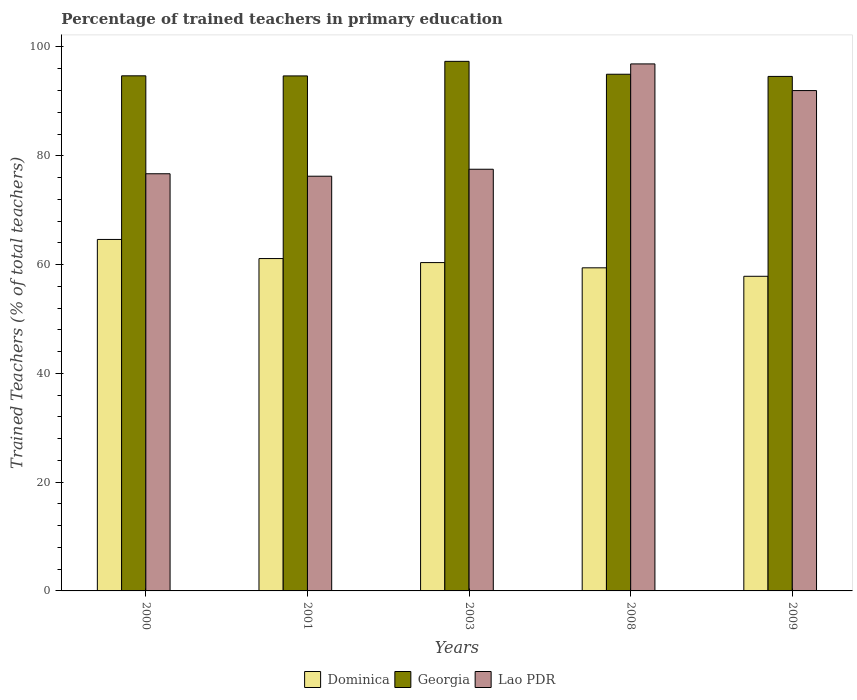How many groups of bars are there?
Ensure brevity in your answer.  5. Are the number of bars on each tick of the X-axis equal?
Your answer should be compact. Yes. How many bars are there on the 2nd tick from the left?
Offer a very short reply. 3. How many bars are there on the 2nd tick from the right?
Offer a very short reply. 3. What is the label of the 4th group of bars from the left?
Give a very brief answer. 2008. In how many cases, is the number of bars for a given year not equal to the number of legend labels?
Offer a very short reply. 0. What is the percentage of trained teachers in Dominica in 2000?
Offer a very short reply. 64.62. Across all years, what is the maximum percentage of trained teachers in Lao PDR?
Your response must be concise. 96.89. Across all years, what is the minimum percentage of trained teachers in Georgia?
Make the answer very short. 94.59. In which year was the percentage of trained teachers in Dominica minimum?
Provide a succinct answer. 2009. What is the total percentage of trained teachers in Dominica in the graph?
Offer a very short reply. 303.33. What is the difference between the percentage of trained teachers in Georgia in 2000 and that in 2009?
Your answer should be very brief. 0.11. What is the difference between the percentage of trained teachers in Georgia in 2008 and the percentage of trained teachers in Lao PDR in 2003?
Your answer should be very brief. 17.47. What is the average percentage of trained teachers in Georgia per year?
Your response must be concise. 95.26. In the year 2008, what is the difference between the percentage of trained teachers in Dominica and percentage of trained teachers in Lao PDR?
Provide a succinct answer. -37.49. In how many years, is the percentage of trained teachers in Dominica greater than 88 %?
Give a very brief answer. 0. What is the ratio of the percentage of trained teachers in Georgia in 2003 to that in 2008?
Offer a very short reply. 1.02. Is the percentage of trained teachers in Dominica in 2008 less than that in 2009?
Give a very brief answer. No. Is the difference between the percentage of trained teachers in Dominica in 2003 and 2009 greater than the difference between the percentage of trained teachers in Lao PDR in 2003 and 2009?
Keep it short and to the point. Yes. What is the difference between the highest and the second highest percentage of trained teachers in Dominica?
Provide a short and direct response. 3.52. What is the difference between the highest and the lowest percentage of trained teachers in Lao PDR?
Offer a very short reply. 20.64. In how many years, is the percentage of trained teachers in Lao PDR greater than the average percentage of trained teachers in Lao PDR taken over all years?
Keep it short and to the point. 2. Is the sum of the percentage of trained teachers in Dominica in 2003 and 2008 greater than the maximum percentage of trained teachers in Lao PDR across all years?
Offer a terse response. Yes. What does the 1st bar from the left in 2009 represents?
Provide a short and direct response. Dominica. What does the 1st bar from the right in 2003 represents?
Your answer should be compact. Lao PDR. How many bars are there?
Your answer should be very brief. 15. Are all the bars in the graph horizontal?
Give a very brief answer. No. How many years are there in the graph?
Ensure brevity in your answer.  5. What is the difference between two consecutive major ticks on the Y-axis?
Offer a terse response. 20. Where does the legend appear in the graph?
Offer a very short reply. Bottom center. How many legend labels are there?
Keep it short and to the point. 3. How are the legend labels stacked?
Make the answer very short. Horizontal. What is the title of the graph?
Provide a succinct answer. Percentage of trained teachers in primary education. Does "Euro area" appear as one of the legend labels in the graph?
Provide a short and direct response. No. What is the label or title of the Y-axis?
Your response must be concise. Trained Teachers (% of total teachers). What is the Trained Teachers (% of total teachers) in Dominica in 2000?
Your answer should be compact. 64.62. What is the Trained Teachers (% of total teachers) of Georgia in 2000?
Keep it short and to the point. 94.7. What is the Trained Teachers (% of total teachers) of Lao PDR in 2000?
Make the answer very short. 76.69. What is the Trained Teachers (% of total teachers) in Dominica in 2001?
Make the answer very short. 61.1. What is the Trained Teachers (% of total teachers) of Georgia in 2001?
Your answer should be very brief. 94.68. What is the Trained Teachers (% of total teachers) in Lao PDR in 2001?
Provide a short and direct response. 76.24. What is the Trained Teachers (% of total teachers) in Dominica in 2003?
Make the answer very short. 60.36. What is the Trained Teachers (% of total teachers) in Georgia in 2003?
Your response must be concise. 97.36. What is the Trained Teachers (% of total teachers) of Lao PDR in 2003?
Make the answer very short. 77.52. What is the Trained Teachers (% of total teachers) in Dominica in 2008?
Your answer should be compact. 59.4. What is the Trained Teachers (% of total teachers) in Georgia in 2008?
Provide a short and direct response. 94.99. What is the Trained Teachers (% of total teachers) of Lao PDR in 2008?
Your response must be concise. 96.89. What is the Trained Teachers (% of total teachers) in Dominica in 2009?
Your response must be concise. 57.84. What is the Trained Teachers (% of total teachers) in Georgia in 2009?
Give a very brief answer. 94.59. What is the Trained Teachers (% of total teachers) of Lao PDR in 2009?
Keep it short and to the point. 91.99. Across all years, what is the maximum Trained Teachers (% of total teachers) of Dominica?
Ensure brevity in your answer.  64.62. Across all years, what is the maximum Trained Teachers (% of total teachers) of Georgia?
Keep it short and to the point. 97.36. Across all years, what is the maximum Trained Teachers (% of total teachers) in Lao PDR?
Provide a succinct answer. 96.89. Across all years, what is the minimum Trained Teachers (% of total teachers) in Dominica?
Offer a terse response. 57.84. Across all years, what is the minimum Trained Teachers (% of total teachers) in Georgia?
Provide a succinct answer. 94.59. Across all years, what is the minimum Trained Teachers (% of total teachers) in Lao PDR?
Provide a succinct answer. 76.24. What is the total Trained Teachers (% of total teachers) in Dominica in the graph?
Your answer should be compact. 303.33. What is the total Trained Teachers (% of total teachers) in Georgia in the graph?
Give a very brief answer. 476.32. What is the total Trained Teachers (% of total teachers) in Lao PDR in the graph?
Your response must be concise. 419.33. What is the difference between the Trained Teachers (% of total teachers) of Dominica in 2000 and that in 2001?
Your answer should be compact. 3.52. What is the difference between the Trained Teachers (% of total teachers) of Georgia in 2000 and that in 2001?
Ensure brevity in your answer.  0.02. What is the difference between the Trained Teachers (% of total teachers) of Lao PDR in 2000 and that in 2001?
Provide a short and direct response. 0.45. What is the difference between the Trained Teachers (% of total teachers) of Dominica in 2000 and that in 2003?
Provide a short and direct response. 4.25. What is the difference between the Trained Teachers (% of total teachers) of Georgia in 2000 and that in 2003?
Your response must be concise. -2.66. What is the difference between the Trained Teachers (% of total teachers) of Lao PDR in 2000 and that in 2003?
Ensure brevity in your answer.  -0.83. What is the difference between the Trained Teachers (% of total teachers) in Dominica in 2000 and that in 2008?
Your answer should be very brief. 5.22. What is the difference between the Trained Teachers (% of total teachers) in Georgia in 2000 and that in 2008?
Ensure brevity in your answer.  -0.29. What is the difference between the Trained Teachers (% of total teachers) of Lao PDR in 2000 and that in 2008?
Keep it short and to the point. -20.19. What is the difference between the Trained Teachers (% of total teachers) of Dominica in 2000 and that in 2009?
Keep it short and to the point. 6.77. What is the difference between the Trained Teachers (% of total teachers) of Georgia in 2000 and that in 2009?
Your answer should be very brief. 0.11. What is the difference between the Trained Teachers (% of total teachers) in Lao PDR in 2000 and that in 2009?
Provide a succinct answer. -15.29. What is the difference between the Trained Teachers (% of total teachers) in Dominica in 2001 and that in 2003?
Make the answer very short. 0.74. What is the difference between the Trained Teachers (% of total teachers) in Georgia in 2001 and that in 2003?
Offer a terse response. -2.68. What is the difference between the Trained Teachers (% of total teachers) in Lao PDR in 2001 and that in 2003?
Your answer should be very brief. -1.28. What is the difference between the Trained Teachers (% of total teachers) in Dominica in 2001 and that in 2008?
Offer a very short reply. 1.7. What is the difference between the Trained Teachers (% of total teachers) of Georgia in 2001 and that in 2008?
Provide a short and direct response. -0.31. What is the difference between the Trained Teachers (% of total teachers) of Lao PDR in 2001 and that in 2008?
Your answer should be compact. -20.64. What is the difference between the Trained Teachers (% of total teachers) of Dominica in 2001 and that in 2009?
Make the answer very short. 3.26. What is the difference between the Trained Teachers (% of total teachers) of Georgia in 2001 and that in 2009?
Your response must be concise. 0.09. What is the difference between the Trained Teachers (% of total teachers) in Lao PDR in 2001 and that in 2009?
Your answer should be very brief. -15.75. What is the difference between the Trained Teachers (% of total teachers) in Dominica in 2003 and that in 2008?
Provide a short and direct response. 0.96. What is the difference between the Trained Teachers (% of total teachers) of Georgia in 2003 and that in 2008?
Offer a terse response. 2.37. What is the difference between the Trained Teachers (% of total teachers) of Lao PDR in 2003 and that in 2008?
Your answer should be compact. -19.36. What is the difference between the Trained Teachers (% of total teachers) of Dominica in 2003 and that in 2009?
Give a very brief answer. 2.52. What is the difference between the Trained Teachers (% of total teachers) of Georgia in 2003 and that in 2009?
Keep it short and to the point. 2.77. What is the difference between the Trained Teachers (% of total teachers) in Lao PDR in 2003 and that in 2009?
Provide a short and direct response. -14.46. What is the difference between the Trained Teachers (% of total teachers) of Dominica in 2008 and that in 2009?
Ensure brevity in your answer.  1.56. What is the difference between the Trained Teachers (% of total teachers) in Georgia in 2008 and that in 2009?
Provide a short and direct response. 0.4. What is the difference between the Trained Teachers (% of total teachers) in Lao PDR in 2008 and that in 2009?
Make the answer very short. 4.9. What is the difference between the Trained Teachers (% of total teachers) of Dominica in 2000 and the Trained Teachers (% of total teachers) of Georgia in 2001?
Offer a very short reply. -30.06. What is the difference between the Trained Teachers (% of total teachers) in Dominica in 2000 and the Trained Teachers (% of total teachers) in Lao PDR in 2001?
Make the answer very short. -11.62. What is the difference between the Trained Teachers (% of total teachers) in Georgia in 2000 and the Trained Teachers (% of total teachers) in Lao PDR in 2001?
Your answer should be very brief. 18.46. What is the difference between the Trained Teachers (% of total teachers) of Dominica in 2000 and the Trained Teachers (% of total teachers) of Georgia in 2003?
Make the answer very short. -32.74. What is the difference between the Trained Teachers (% of total teachers) in Dominica in 2000 and the Trained Teachers (% of total teachers) in Lao PDR in 2003?
Your answer should be compact. -12.9. What is the difference between the Trained Teachers (% of total teachers) in Georgia in 2000 and the Trained Teachers (% of total teachers) in Lao PDR in 2003?
Offer a terse response. 17.18. What is the difference between the Trained Teachers (% of total teachers) in Dominica in 2000 and the Trained Teachers (% of total teachers) in Georgia in 2008?
Make the answer very short. -30.37. What is the difference between the Trained Teachers (% of total teachers) in Dominica in 2000 and the Trained Teachers (% of total teachers) in Lao PDR in 2008?
Provide a succinct answer. -32.27. What is the difference between the Trained Teachers (% of total teachers) of Georgia in 2000 and the Trained Teachers (% of total teachers) of Lao PDR in 2008?
Your answer should be compact. -2.19. What is the difference between the Trained Teachers (% of total teachers) of Dominica in 2000 and the Trained Teachers (% of total teachers) of Georgia in 2009?
Provide a succinct answer. -29.97. What is the difference between the Trained Teachers (% of total teachers) of Dominica in 2000 and the Trained Teachers (% of total teachers) of Lao PDR in 2009?
Provide a succinct answer. -27.37. What is the difference between the Trained Teachers (% of total teachers) of Georgia in 2000 and the Trained Teachers (% of total teachers) of Lao PDR in 2009?
Offer a very short reply. 2.71. What is the difference between the Trained Teachers (% of total teachers) in Dominica in 2001 and the Trained Teachers (% of total teachers) in Georgia in 2003?
Provide a short and direct response. -36.26. What is the difference between the Trained Teachers (% of total teachers) of Dominica in 2001 and the Trained Teachers (% of total teachers) of Lao PDR in 2003?
Give a very brief answer. -16.42. What is the difference between the Trained Teachers (% of total teachers) of Georgia in 2001 and the Trained Teachers (% of total teachers) of Lao PDR in 2003?
Keep it short and to the point. 17.16. What is the difference between the Trained Teachers (% of total teachers) of Dominica in 2001 and the Trained Teachers (% of total teachers) of Georgia in 2008?
Your answer should be compact. -33.89. What is the difference between the Trained Teachers (% of total teachers) of Dominica in 2001 and the Trained Teachers (% of total teachers) of Lao PDR in 2008?
Your answer should be very brief. -35.78. What is the difference between the Trained Teachers (% of total teachers) of Georgia in 2001 and the Trained Teachers (% of total teachers) of Lao PDR in 2008?
Your answer should be compact. -2.2. What is the difference between the Trained Teachers (% of total teachers) in Dominica in 2001 and the Trained Teachers (% of total teachers) in Georgia in 2009?
Provide a succinct answer. -33.49. What is the difference between the Trained Teachers (% of total teachers) of Dominica in 2001 and the Trained Teachers (% of total teachers) of Lao PDR in 2009?
Offer a terse response. -30.89. What is the difference between the Trained Teachers (% of total teachers) in Georgia in 2001 and the Trained Teachers (% of total teachers) in Lao PDR in 2009?
Provide a short and direct response. 2.69. What is the difference between the Trained Teachers (% of total teachers) in Dominica in 2003 and the Trained Teachers (% of total teachers) in Georgia in 2008?
Provide a short and direct response. -34.63. What is the difference between the Trained Teachers (% of total teachers) of Dominica in 2003 and the Trained Teachers (% of total teachers) of Lao PDR in 2008?
Your answer should be very brief. -36.52. What is the difference between the Trained Teachers (% of total teachers) of Georgia in 2003 and the Trained Teachers (% of total teachers) of Lao PDR in 2008?
Ensure brevity in your answer.  0.47. What is the difference between the Trained Teachers (% of total teachers) of Dominica in 2003 and the Trained Teachers (% of total teachers) of Georgia in 2009?
Give a very brief answer. -34.23. What is the difference between the Trained Teachers (% of total teachers) in Dominica in 2003 and the Trained Teachers (% of total teachers) in Lao PDR in 2009?
Your response must be concise. -31.62. What is the difference between the Trained Teachers (% of total teachers) of Georgia in 2003 and the Trained Teachers (% of total teachers) of Lao PDR in 2009?
Provide a succinct answer. 5.37. What is the difference between the Trained Teachers (% of total teachers) in Dominica in 2008 and the Trained Teachers (% of total teachers) in Georgia in 2009?
Offer a terse response. -35.19. What is the difference between the Trained Teachers (% of total teachers) in Dominica in 2008 and the Trained Teachers (% of total teachers) in Lao PDR in 2009?
Ensure brevity in your answer.  -32.59. What is the difference between the Trained Teachers (% of total teachers) of Georgia in 2008 and the Trained Teachers (% of total teachers) of Lao PDR in 2009?
Ensure brevity in your answer.  3. What is the average Trained Teachers (% of total teachers) in Dominica per year?
Provide a succinct answer. 60.67. What is the average Trained Teachers (% of total teachers) of Georgia per year?
Provide a succinct answer. 95.26. What is the average Trained Teachers (% of total teachers) of Lao PDR per year?
Keep it short and to the point. 83.87. In the year 2000, what is the difference between the Trained Teachers (% of total teachers) in Dominica and Trained Teachers (% of total teachers) in Georgia?
Offer a very short reply. -30.08. In the year 2000, what is the difference between the Trained Teachers (% of total teachers) in Dominica and Trained Teachers (% of total teachers) in Lao PDR?
Provide a short and direct response. -12.07. In the year 2000, what is the difference between the Trained Teachers (% of total teachers) of Georgia and Trained Teachers (% of total teachers) of Lao PDR?
Provide a succinct answer. 18.01. In the year 2001, what is the difference between the Trained Teachers (% of total teachers) in Dominica and Trained Teachers (% of total teachers) in Georgia?
Ensure brevity in your answer.  -33.58. In the year 2001, what is the difference between the Trained Teachers (% of total teachers) in Dominica and Trained Teachers (% of total teachers) in Lao PDR?
Keep it short and to the point. -15.14. In the year 2001, what is the difference between the Trained Teachers (% of total teachers) in Georgia and Trained Teachers (% of total teachers) in Lao PDR?
Make the answer very short. 18.44. In the year 2003, what is the difference between the Trained Teachers (% of total teachers) in Dominica and Trained Teachers (% of total teachers) in Georgia?
Your answer should be compact. -36.99. In the year 2003, what is the difference between the Trained Teachers (% of total teachers) in Dominica and Trained Teachers (% of total teachers) in Lao PDR?
Give a very brief answer. -17.16. In the year 2003, what is the difference between the Trained Teachers (% of total teachers) in Georgia and Trained Teachers (% of total teachers) in Lao PDR?
Your answer should be compact. 19.83. In the year 2008, what is the difference between the Trained Teachers (% of total teachers) of Dominica and Trained Teachers (% of total teachers) of Georgia?
Keep it short and to the point. -35.59. In the year 2008, what is the difference between the Trained Teachers (% of total teachers) of Dominica and Trained Teachers (% of total teachers) of Lao PDR?
Make the answer very short. -37.49. In the year 2008, what is the difference between the Trained Teachers (% of total teachers) of Georgia and Trained Teachers (% of total teachers) of Lao PDR?
Offer a terse response. -1.9. In the year 2009, what is the difference between the Trained Teachers (% of total teachers) of Dominica and Trained Teachers (% of total teachers) of Georgia?
Your answer should be compact. -36.75. In the year 2009, what is the difference between the Trained Teachers (% of total teachers) of Dominica and Trained Teachers (% of total teachers) of Lao PDR?
Give a very brief answer. -34.14. In the year 2009, what is the difference between the Trained Teachers (% of total teachers) in Georgia and Trained Teachers (% of total teachers) in Lao PDR?
Provide a succinct answer. 2.6. What is the ratio of the Trained Teachers (% of total teachers) of Dominica in 2000 to that in 2001?
Keep it short and to the point. 1.06. What is the ratio of the Trained Teachers (% of total teachers) of Lao PDR in 2000 to that in 2001?
Provide a succinct answer. 1.01. What is the ratio of the Trained Teachers (% of total teachers) of Dominica in 2000 to that in 2003?
Give a very brief answer. 1.07. What is the ratio of the Trained Teachers (% of total teachers) in Georgia in 2000 to that in 2003?
Make the answer very short. 0.97. What is the ratio of the Trained Teachers (% of total teachers) in Lao PDR in 2000 to that in 2003?
Provide a succinct answer. 0.99. What is the ratio of the Trained Teachers (% of total teachers) in Dominica in 2000 to that in 2008?
Provide a short and direct response. 1.09. What is the ratio of the Trained Teachers (% of total teachers) of Georgia in 2000 to that in 2008?
Offer a very short reply. 1. What is the ratio of the Trained Teachers (% of total teachers) in Lao PDR in 2000 to that in 2008?
Your response must be concise. 0.79. What is the ratio of the Trained Teachers (% of total teachers) in Dominica in 2000 to that in 2009?
Give a very brief answer. 1.12. What is the ratio of the Trained Teachers (% of total teachers) of Georgia in 2000 to that in 2009?
Make the answer very short. 1. What is the ratio of the Trained Teachers (% of total teachers) in Lao PDR in 2000 to that in 2009?
Provide a succinct answer. 0.83. What is the ratio of the Trained Teachers (% of total teachers) in Dominica in 2001 to that in 2003?
Offer a very short reply. 1.01. What is the ratio of the Trained Teachers (% of total teachers) in Georgia in 2001 to that in 2003?
Give a very brief answer. 0.97. What is the ratio of the Trained Teachers (% of total teachers) in Lao PDR in 2001 to that in 2003?
Provide a short and direct response. 0.98. What is the ratio of the Trained Teachers (% of total teachers) of Dominica in 2001 to that in 2008?
Ensure brevity in your answer.  1.03. What is the ratio of the Trained Teachers (% of total teachers) in Lao PDR in 2001 to that in 2008?
Your response must be concise. 0.79. What is the ratio of the Trained Teachers (% of total teachers) in Dominica in 2001 to that in 2009?
Your answer should be compact. 1.06. What is the ratio of the Trained Teachers (% of total teachers) in Georgia in 2001 to that in 2009?
Make the answer very short. 1. What is the ratio of the Trained Teachers (% of total teachers) of Lao PDR in 2001 to that in 2009?
Provide a succinct answer. 0.83. What is the ratio of the Trained Teachers (% of total teachers) of Dominica in 2003 to that in 2008?
Your answer should be compact. 1.02. What is the ratio of the Trained Teachers (% of total teachers) in Georgia in 2003 to that in 2008?
Provide a short and direct response. 1.02. What is the ratio of the Trained Teachers (% of total teachers) in Lao PDR in 2003 to that in 2008?
Your response must be concise. 0.8. What is the ratio of the Trained Teachers (% of total teachers) in Dominica in 2003 to that in 2009?
Provide a short and direct response. 1.04. What is the ratio of the Trained Teachers (% of total teachers) in Georgia in 2003 to that in 2009?
Your answer should be compact. 1.03. What is the ratio of the Trained Teachers (% of total teachers) of Lao PDR in 2003 to that in 2009?
Your response must be concise. 0.84. What is the ratio of the Trained Teachers (% of total teachers) of Dominica in 2008 to that in 2009?
Make the answer very short. 1.03. What is the ratio of the Trained Teachers (% of total teachers) of Lao PDR in 2008 to that in 2009?
Provide a succinct answer. 1.05. What is the difference between the highest and the second highest Trained Teachers (% of total teachers) of Dominica?
Offer a terse response. 3.52. What is the difference between the highest and the second highest Trained Teachers (% of total teachers) in Georgia?
Offer a terse response. 2.37. What is the difference between the highest and the second highest Trained Teachers (% of total teachers) of Lao PDR?
Your answer should be very brief. 4.9. What is the difference between the highest and the lowest Trained Teachers (% of total teachers) in Dominica?
Offer a terse response. 6.77. What is the difference between the highest and the lowest Trained Teachers (% of total teachers) in Georgia?
Offer a terse response. 2.77. What is the difference between the highest and the lowest Trained Teachers (% of total teachers) in Lao PDR?
Ensure brevity in your answer.  20.64. 